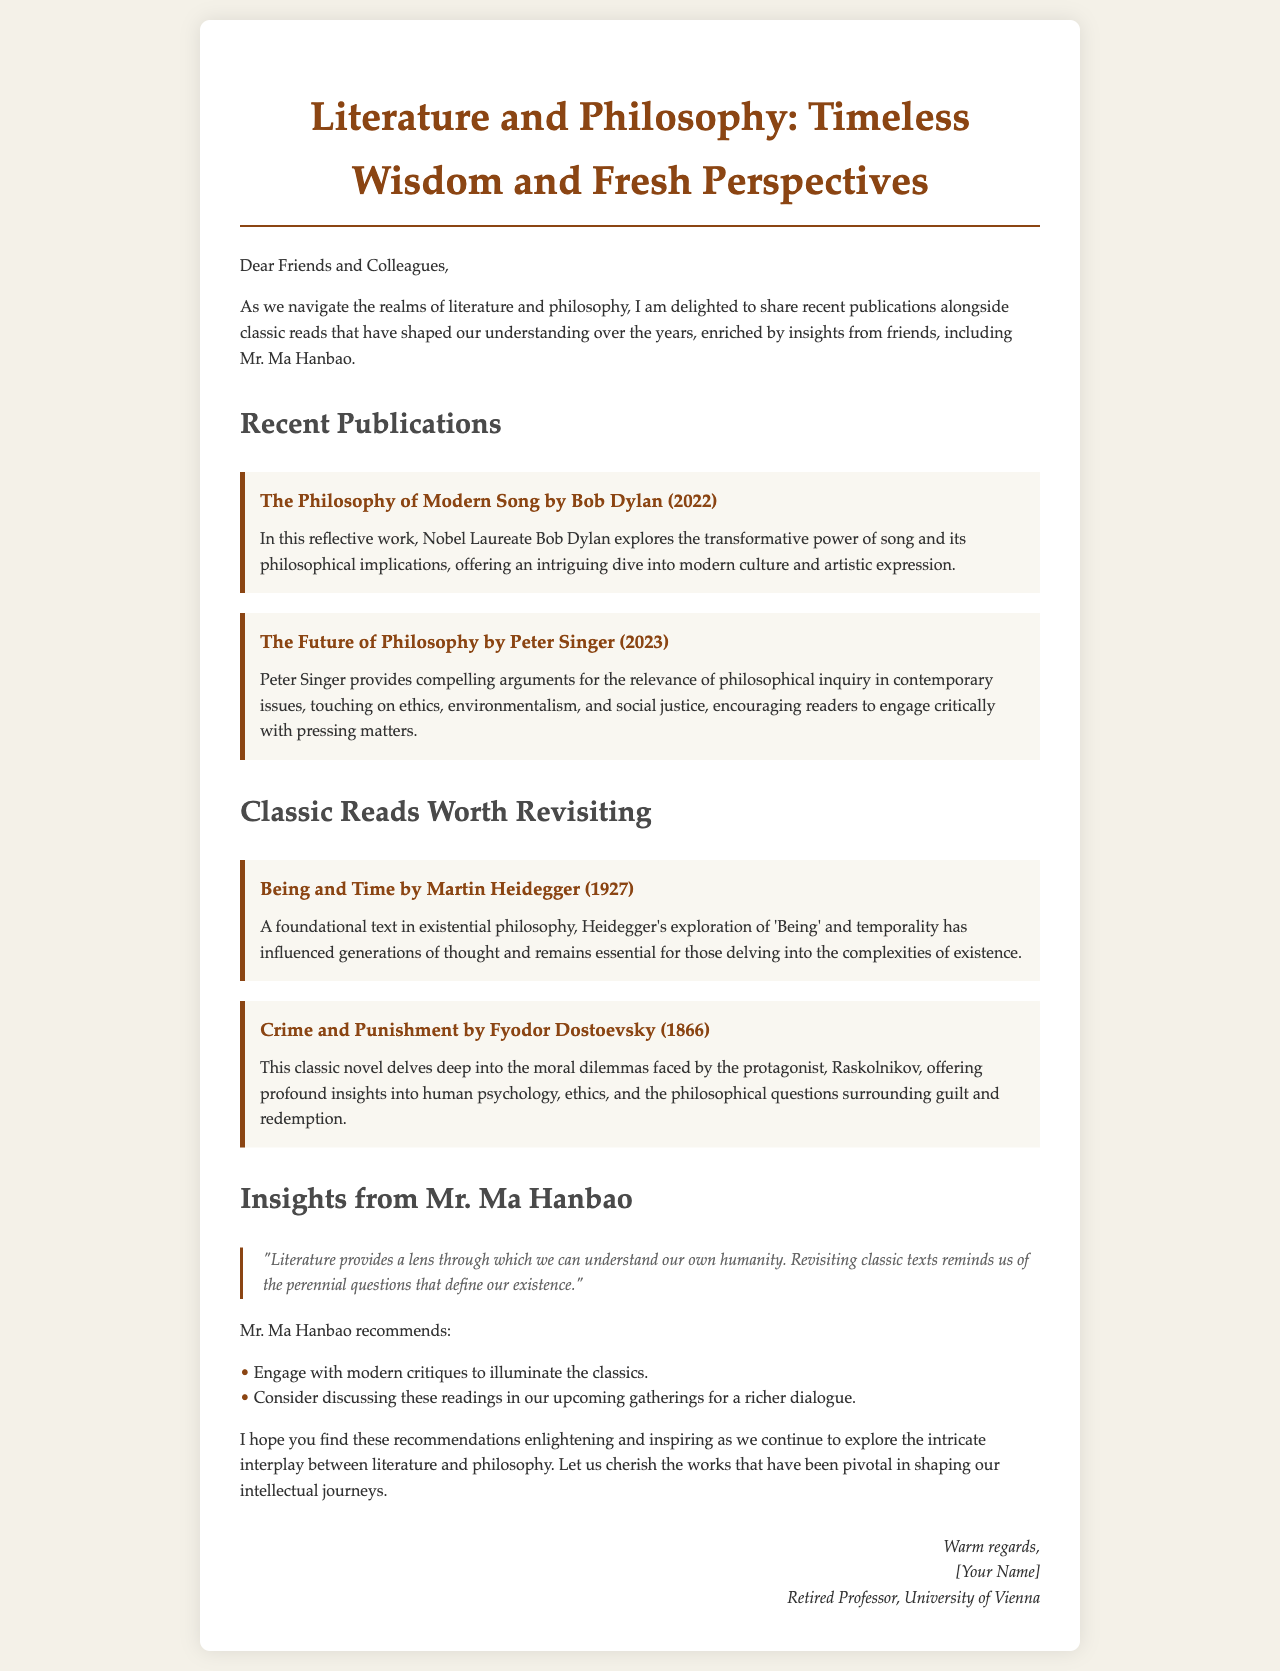what is the title of the recent publication by Bob Dylan? The document lists "The Philosophy of Modern Song" as the title of the recent publication by Bob Dylan.
Answer: The Philosophy of Modern Song who is the author of "The Future of Philosophy"? The author of "The Future of Philosophy" is identified as Peter Singer in the document.
Answer: Peter Singer in what year was "Crime and Punishment" published? The document states that "Crime and Punishment" was published in 1866.
Answer: 1866 what philosophical theme does Heidegger's "Being and Time" explore? The document indicates that Heidegger's "Being and Time" explores the theme of 'Being' and temporality.
Answer: 'Being' and temporality who provided insights quoted in the newsletter? The insights quoted in the newsletter are attributed to Mr. Ma Hanbao.
Answer: Mr. Ma Hanbao how does Mr. Ma Hanbao suggest engaging with classic texts? Mr. Ma Hanbao suggests engaging with modern critiques to illuminate the classics.
Answer: modern critiques what is the overall theme of the newsletter? The overall theme of the newsletter is the interplay between literature and philosophy, highlighting both recent publications and classic reads.
Answer: interplay between literature and philosophy how does the document categorize the recommended readings? The document categorizes the recommended readings into two sections: Recent Publications and Classic Reads Worth Revisiting.
Answer: Recent Publications and Classic Reads Worth Revisiting what kind of dialogue does Mr. Ma Hanbao recommend for upcoming gatherings? Mr. Ma Hanbao recommends discussing the readings for a richer dialogue.
Answer: discussing the readings for a richer dialogue 